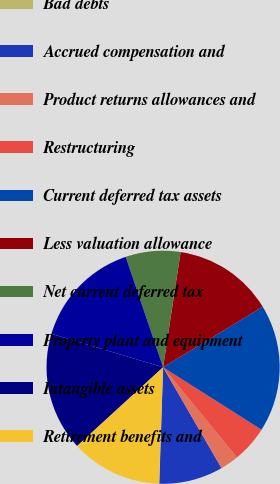<chart> <loc_0><loc_0><loc_500><loc_500><pie_chart><fcel>Bad debts<fcel>Accrued compensation and<fcel>Product returns allowances and<fcel>Restructuring<fcel>Current deferred tax assets<fcel>Less valuation allowance<fcel>Net current deferred tax<fcel>Property plant and equipment<fcel>Intangible assets<fcel>Retirement benefits and<nl><fcel>0.04%<fcel>8.87%<fcel>2.56%<fcel>5.08%<fcel>17.69%<fcel>13.91%<fcel>7.6%<fcel>15.17%<fcel>16.43%<fcel>12.65%<nl></chart> 